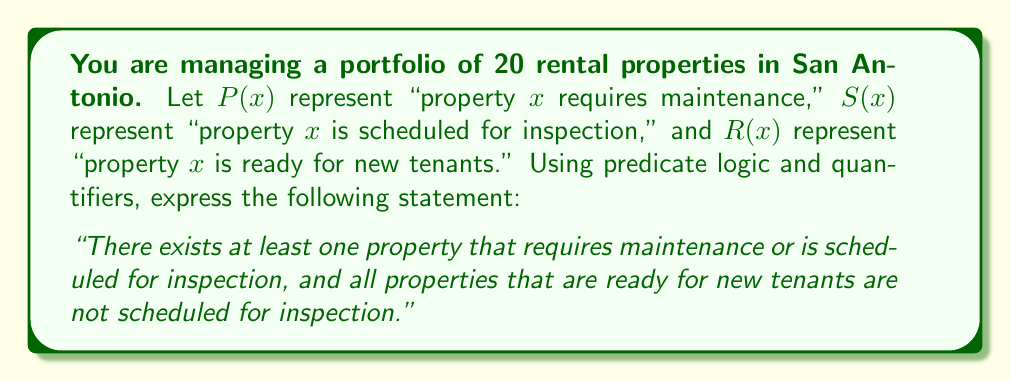What is the answer to this math problem? To express this statement using predicate logic and quantifiers, we need to break it down into two parts and then combine them:

1. "There exists at least one property that requires maintenance or is scheduled for inspection"
   This can be expressed as: $$\exists x (P(x) \lor S(x))$$
   Where $\exists$ is the existential quantifier, meaning "there exists."

2. "All properties that are ready for new tenants are not scheduled for inspection"
   This can be expressed as: $$\forall x (R(x) \rightarrow \neg S(x))$$
   Where $\forall$ is the universal quantifier, meaning "for all," and $\rightarrow$ represents implication.

To combine these two statements, we use the logical AND operator ($\land$):

$$[\exists x (P(x) \lor S(x))] \land [\forall x (R(x) \rightarrow \neg S(x))]$$

This logical expression captures the entire statement, ensuring that:
a) At least one property in the portfolio requires maintenance or is scheduled for inspection.
b) Any property that is ready for new tenants is not scheduled for inspection.

This formulation helps optimize property management schedules by clearly defining the relationships between maintenance needs, inspection schedules, and property readiness for new tenants.
Answer: $$[\exists x (P(x) \lor S(x))] \land [\forall x (R(x) \rightarrow \neg S(x))]$$ 